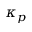<formula> <loc_0><loc_0><loc_500><loc_500>\kappa _ { p }</formula> 